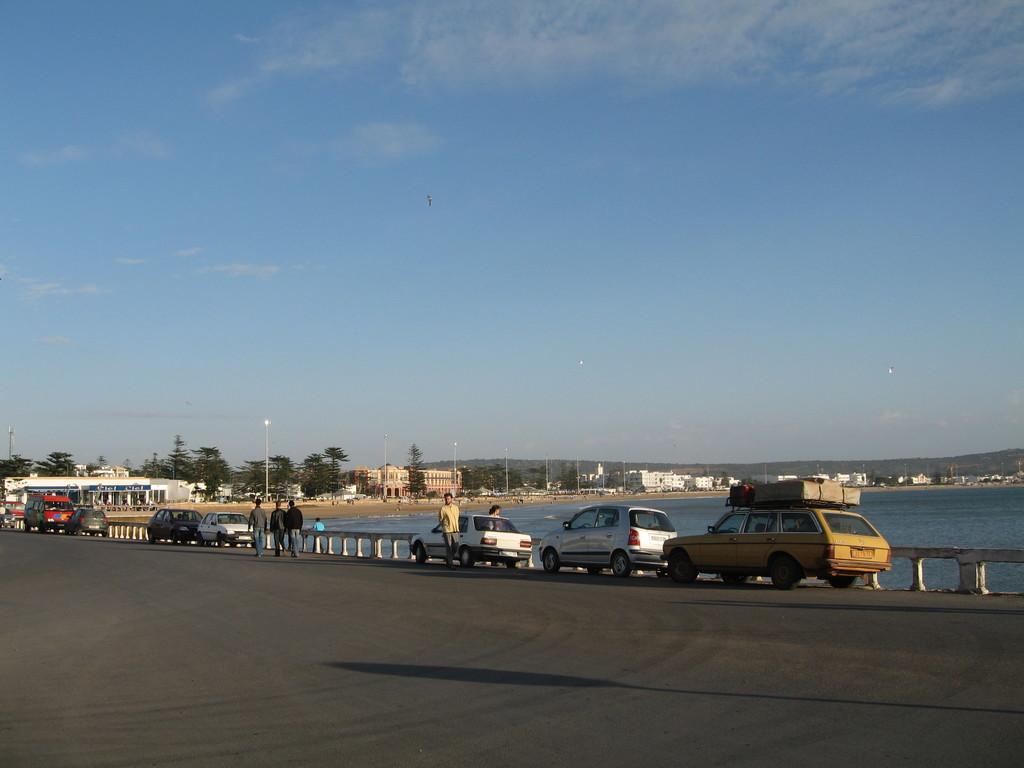In one or two sentences, can you explain what this image depicts? In the background we can see the sky, hills, trees and buildings. In this picture we can see the poles, water and the railing. We can see the vehicles on the road. We can see the people. On the right side of the picture there is luggage on the top of a yellow car. 